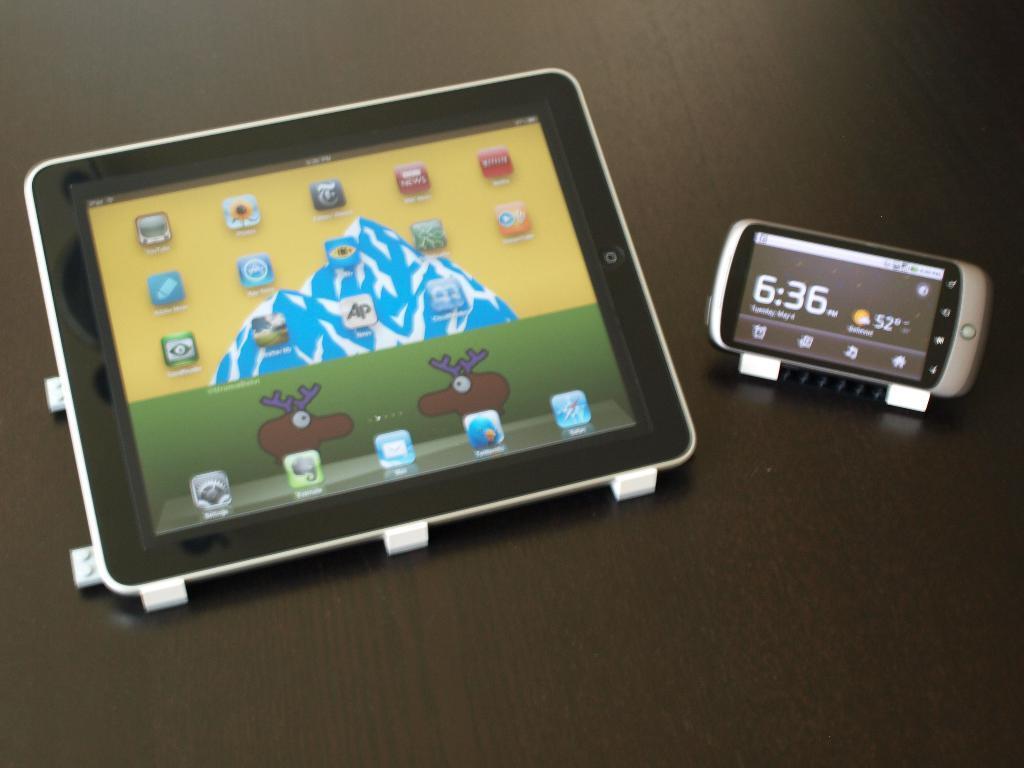Describe this image in one or two sentences. In this image we can see a tablet and a mobile phone on the surface, which looks like a table. 